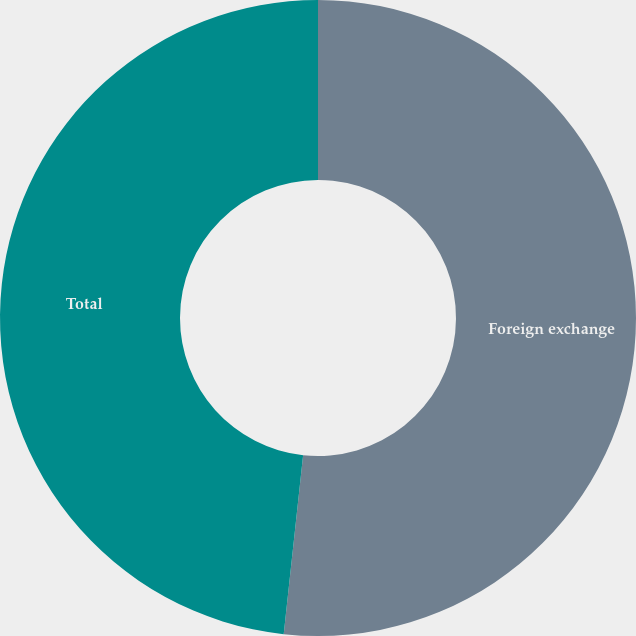Convert chart to OTSL. <chart><loc_0><loc_0><loc_500><loc_500><pie_chart><fcel>Foreign exchange<fcel>Total<nl><fcel>51.72%<fcel>48.28%<nl></chart> 